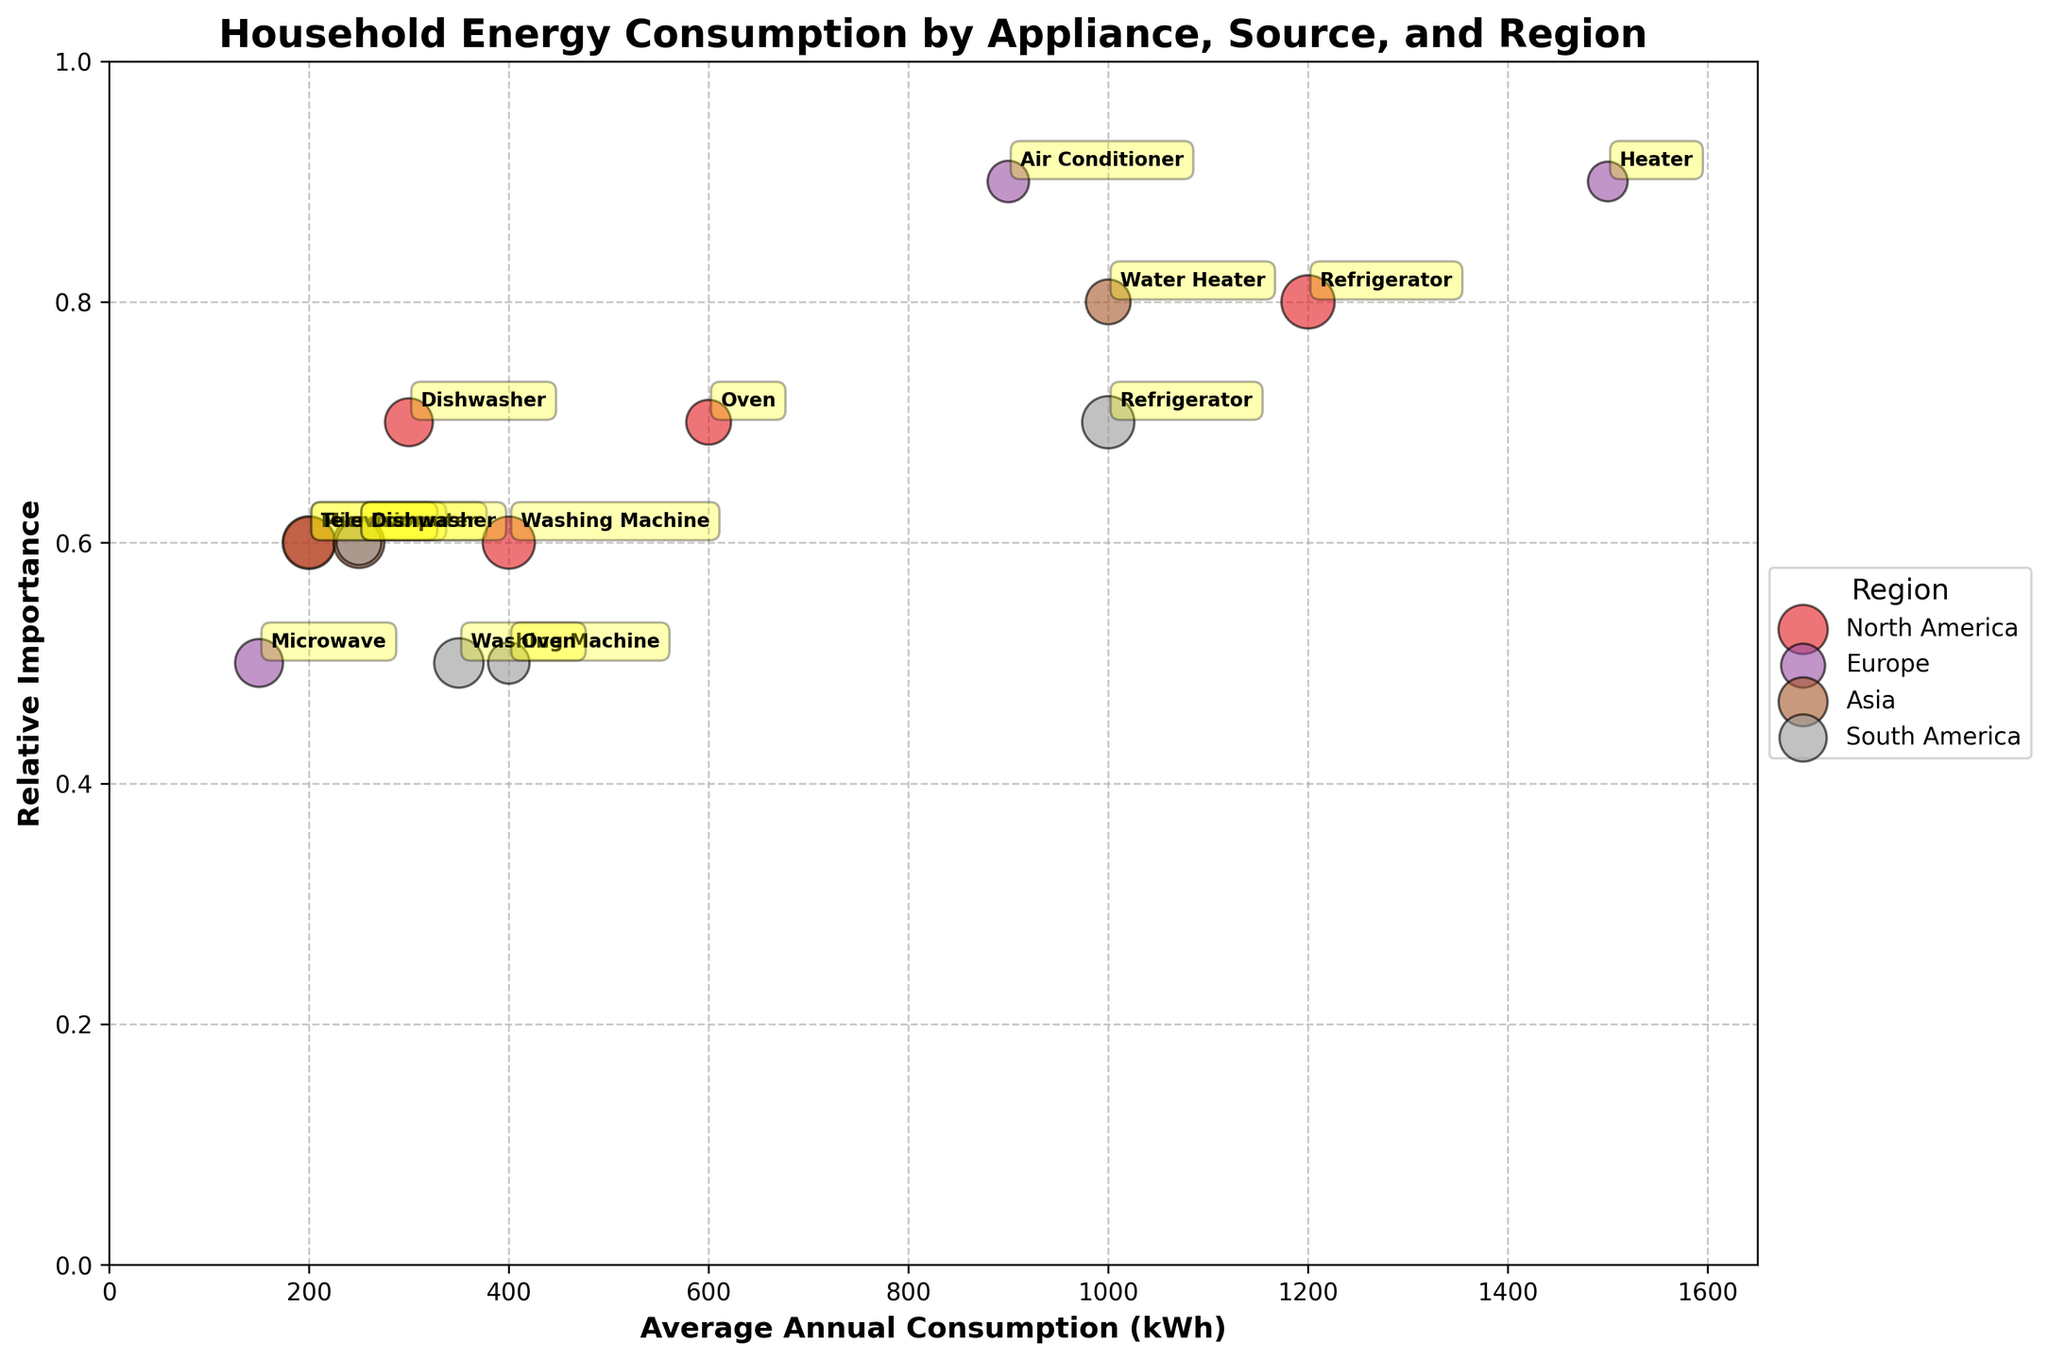What is the title of the figure? The title of the figure is typically found at the top of the chart. It provides a concise summary of what the chart depicts. In this case, it reads 'Household Energy Consumption by Appliance, Source, and Region'.
Answer: Household Energy Consumption by Appliance, Source, and Region What ranges do the x-axis and y-axis cover? The x-axis represents 'Average Annual Consumption (kWh)' and it ranges from 0 to slightly more than the maximum value in the data set, specifically around 1650 kWh. The y-axis represents 'Relative Importance' and ranges from 0 to 1.
Answer: 0 to 1650 kWh; 0 to 1 Which region has the highest average annual consumption for a single appliance type, and what is the value? From the chart, we can identify the largest x-value where a bubble appears. In this case, Europe has this highest value with the 'Heater' appliance consuming 1500 kWh annually.
Answer: Europe, 1500 kWh Which appliance is most significant in terms of relative importance in Europe and what is its importance factor? We need to find the highest y-value among the bubbles labeled with European appliances. Europe’s 'Air Conditioner' and 'Heater' both have the highest relative importance of 0.9.
Answer: Air Conditioner and Heater, 0.9 Compare the average annual consumption of washing machines in North America and South America. Which one consumes more energy and by how much? The bubbles for 'Washing Machine' are plotted on the x-axis in both regions. North America has 400 kWh, and South America has 350 kWh. The difference is 400 - 350 = 50 kWh, with North America consuming more.
Answer: North America, 50 kWh What is the relationship between the size of the bubbles and usage penetration percentage? The size of each bubble is directly proportional to the 'Usage Penetration Percentage' value for each appliance. This means larger bubbles indicate higher penetration. For example, the largest bubbles correspond to percentages like 99%, 97%, etc.
Answer: Direct proportionality Identify the appliance with the highest usage penetration in Asia and provide its percentage. We look for the largest bubble within the Asian region. The largest bubble is labeled 'Television' and has a usage penetration percentage of 97%.
Answer: Television, 97% What pattern do you observe about the appliances using gas across all regions in terms of their relative importance? Appliances using gas are plotted with titles like 'Oven' for North America and South America, and 'Heater' in Europe. The relative importance values for all gas appliances tend to hover around 0.7 with the exception of 'Heater' in Europe which is at 0.9.
Answer: Mostly around 0.7, except Heater in Europe at 0.9 How does the relative importance of refrigerators compare between North America and South America? We compare the y-values of the 'Refrigerator' bubbles. In North America, the relative importance is 0.8 while in South America it is 0.7. Thus, North America's refrigerator has a higher relative importance by 0.1.
Answer: North America, by 0.1 